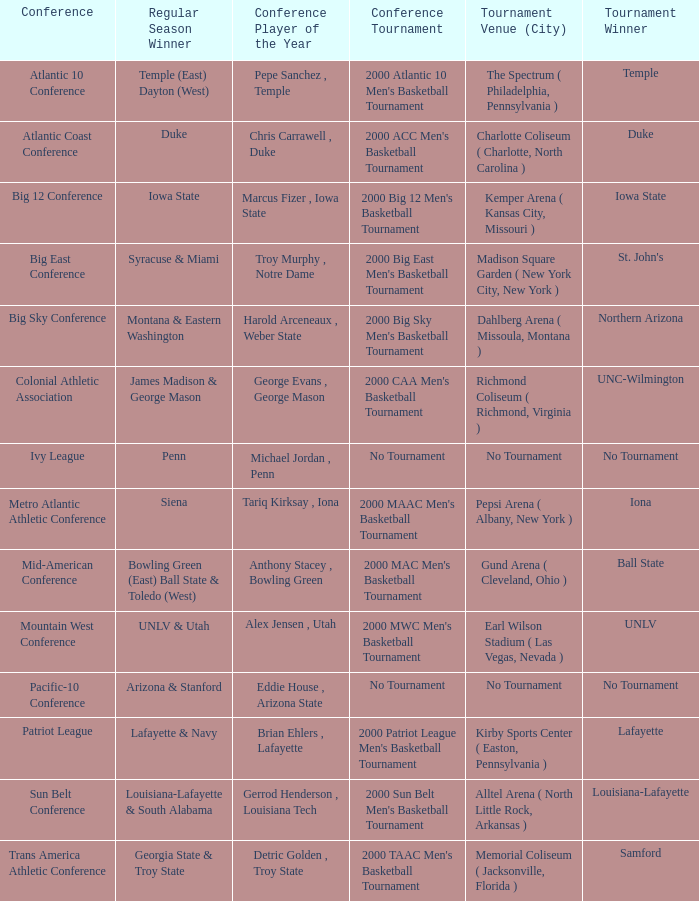Who is the regular season champion for the ivy league conference? Penn. 